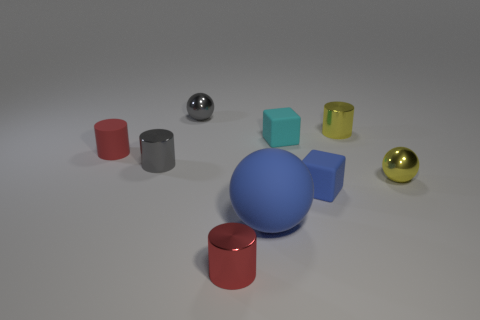There is a matte object that is the same color as the matte ball; what is its shape?
Keep it short and to the point. Cube. What number of other things are there of the same shape as the red matte thing?
Your answer should be very brief. 3. The tiny cyan matte object has what shape?
Your response must be concise. Cube. Is the material of the small gray ball the same as the cyan cube?
Keep it short and to the point. No. Is the number of tiny metallic spheres on the left side of the tiny red metal thing the same as the number of gray balls that are in front of the large blue matte ball?
Provide a short and direct response. No. Is there a metallic thing right of the blue matte thing that is in front of the blue thing right of the large rubber thing?
Your response must be concise. Yes. Do the yellow cylinder and the blue sphere have the same size?
Provide a succinct answer. No. The tiny cube in front of the small ball that is in front of the tiny matte block that is behind the tiny yellow metallic ball is what color?
Your answer should be compact. Blue. What number of tiny matte blocks are the same color as the large object?
Give a very brief answer. 1. How many big objects are either metal spheres or yellow shiny spheres?
Your answer should be very brief. 0. 